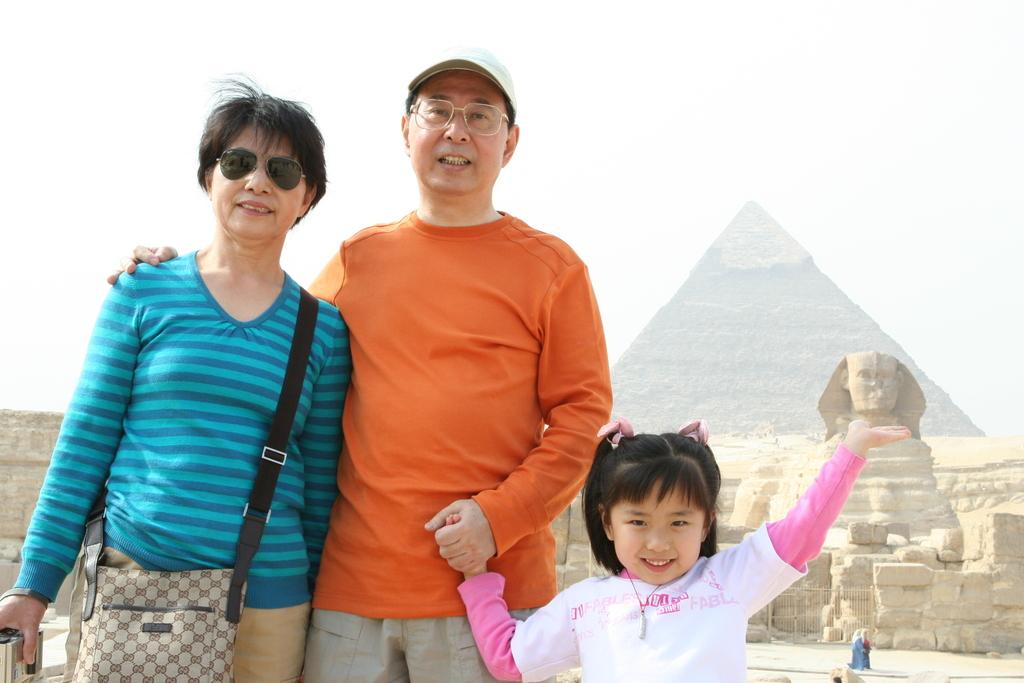How many people are present in the image? There are two people in the image. Can you describe one of the individuals in the image? There is a kid in the image. What type of objects can be seen in the image besides the people? There are sculptures visible in the image. What else might be present in the image that hasn't been mentioned? There are other unspecified things in the image. What type of appliance can be seen in the image? There is no appliance present in the image. How many frogs are visible in the image? There are no frogs visible in the image. 